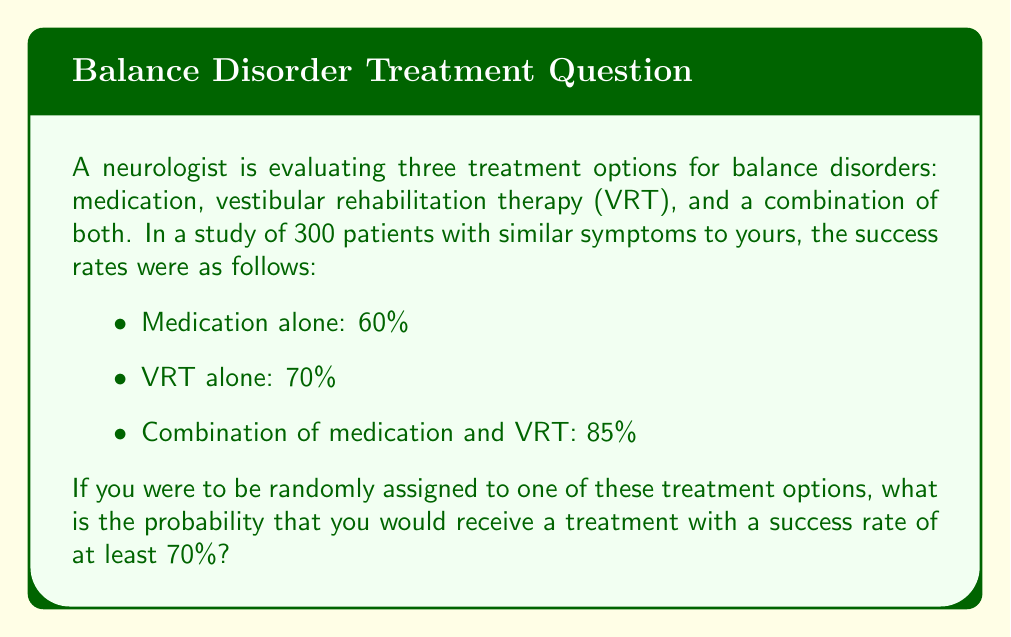Solve this math problem. To solve this problem, we need to follow these steps:

1. Identify the treatments with a success rate of at least 70%:
   - VRT alone: 70%
   - Combination of medication and VRT: 85%

2. Calculate the probability of being assigned to each treatment:
   Since there are three treatment options, and the assignment is random, the probability of being assigned to each treatment is $\frac{1}{3}$.

3. Calculate the probability of receiving a treatment with a success rate of at least 70%:
   This is the sum of the probabilities of being assigned to VRT alone or the combination treatment.

   $$P(\text{success rate} \geq 70\%) = P(\text{VRT}) + P(\text{Combination})$$
   $$P(\text{success rate} \geq 70\%) = \frac{1}{3} + \frac{1}{3} = \frac{2}{3}$$

Therefore, the probability of receiving a treatment with a success rate of at least 70% is $\frac{2}{3}$ or approximately 0.6667.
Answer: $\frac{2}{3}$ 